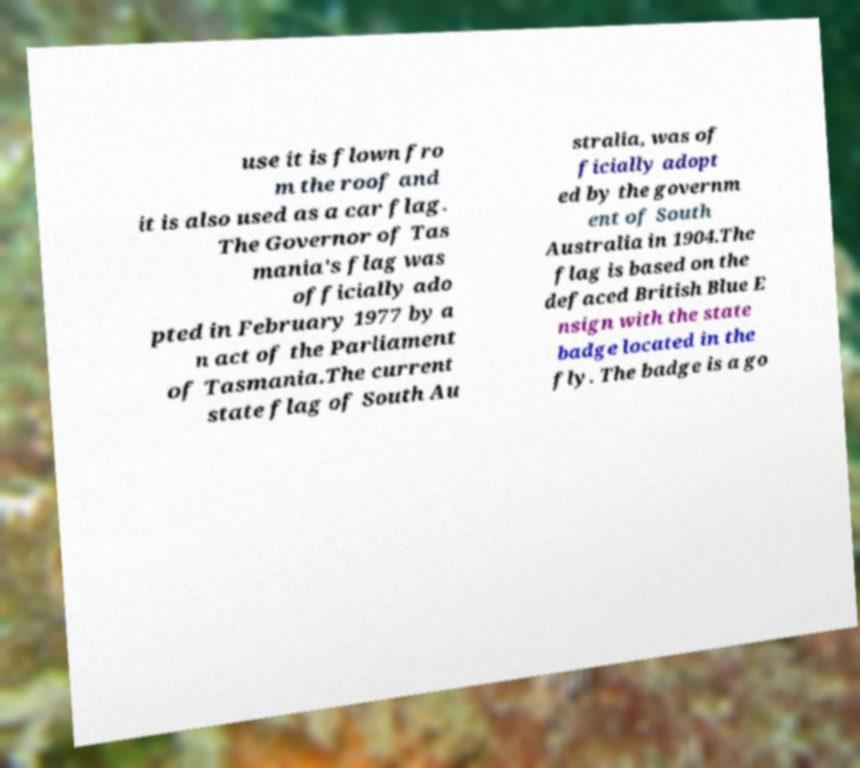I need the written content from this picture converted into text. Can you do that? use it is flown fro m the roof and it is also used as a car flag. The Governor of Tas mania's flag was officially ado pted in February 1977 by a n act of the Parliament of Tasmania.The current state flag of South Au stralia, was of ficially adopt ed by the governm ent of South Australia in 1904.The flag is based on the defaced British Blue E nsign with the state badge located in the fly. The badge is a go 